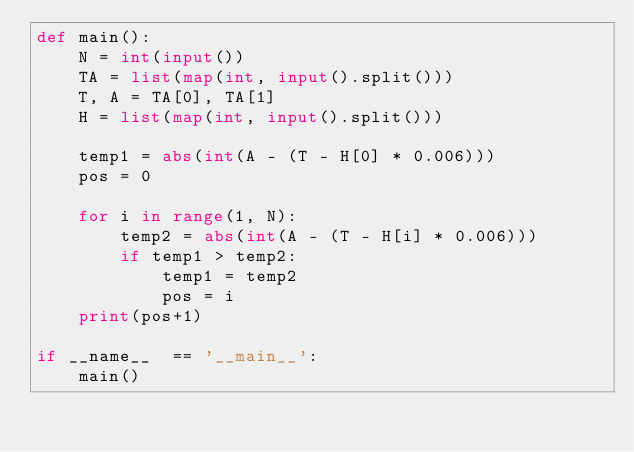Convert code to text. <code><loc_0><loc_0><loc_500><loc_500><_Python_>def main():
    N = int(input())
    TA = list(map(int, input().split()))
    T, A = TA[0], TA[1]
    H = list(map(int, input().split()))

    temp1 = abs(int(A - (T - H[0] * 0.006)))
    pos = 0

    for i in range(1, N):
        temp2 = abs(int(A - (T - H[i] * 0.006)))
        if temp1 > temp2:
            temp1 = temp2
            pos = i
    print(pos+1)

if __name__  == '__main__':
    main()
</code> 